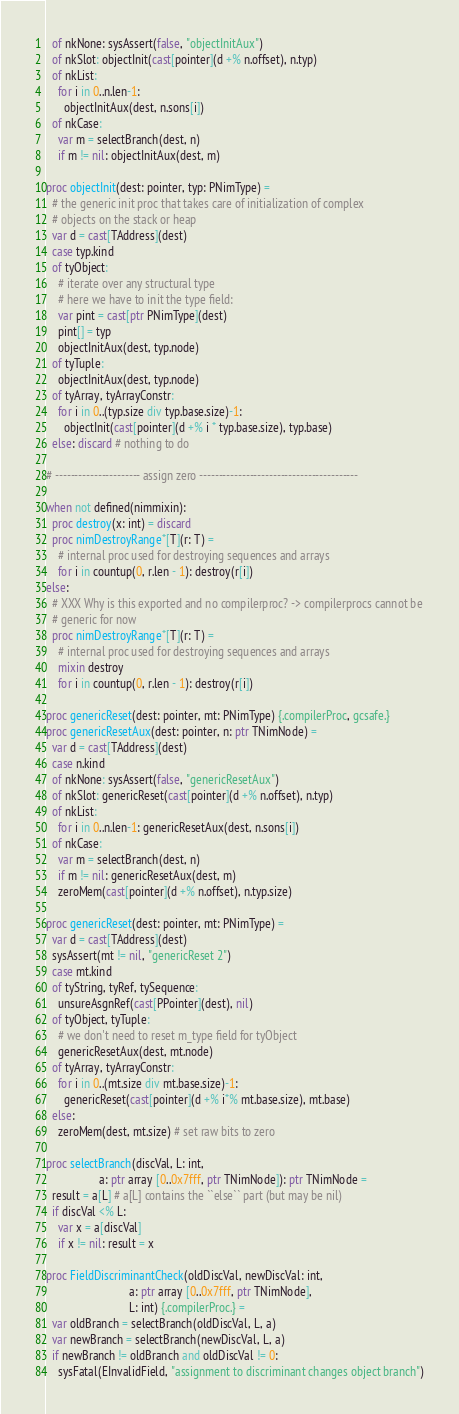<code> <loc_0><loc_0><loc_500><loc_500><_Nim_>  of nkNone: sysAssert(false, "objectInitAux")
  of nkSlot: objectInit(cast[pointer](d +% n.offset), n.typ)
  of nkList:
    for i in 0..n.len-1:
      objectInitAux(dest, n.sons[i])
  of nkCase:
    var m = selectBranch(dest, n)
    if m != nil: objectInitAux(dest, m)

proc objectInit(dest: pointer, typ: PNimType) =
  # the generic init proc that takes care of initialization of complex
  # objects on the stack or heap
  var d = cast[TAddress](dest)
  case typ.kind
  of tyObject:
    # iterate over any structural type
    # here we have to init the type field:
    var pint = cast[ptr PNimType](dest)
    pint[] = typ
    objectInitAux(dest, typ.node)
  of tyTuple:
    objectInitAux(dest, typ.node)
  of tyArray, tyArrayConstr:
    for i in 0..(typ.size div typ.base.size)-1:
      objectInit(cast[pointer](d +% i * typ.base.size), typ.base)
  else: discard # nothing to do
  
# ---------------------- assign zero -----------------------------------------

when not defined(nimmixin):
  proc destroy(x: int) = discard
  proc nimDestroyRange*[T](r: T) =
    # internal proc used for destroying sequences and arrays
    for i in countup(0, r.len - 1): destroy(r[i])
else:
  # XXX Why is this exported and no compilerproc? -> compilerprocs cannot be
  # generic for now
  proc nimDestroyRange*[T](r: T) =
    # internal proc used for destroying sequences and arrays
    mixin destroy
    for i in countup(0, r.len - 1): destroy(r[i])

proc genericReset(dest: pointer, mt: PNimType) {.compilerProc, gcsafe.}
proc genericResetAux(dest: pointer, n: ptr TNimNode) =
  var d = cast[TAddress](dest)
  case n.kind
  of nkNone: sysAssert(false, "genericResetAux")
  of nkSlot: genericReset(cast[pointer](d +% n.offset), n.typ)
  of nkList:
    for i in 0..n.len-1: genericResetAux(dest, n.sons[i])
  of nkCase:
    var m = selectBranch(dest, n)
    if m != nil: genericResetAux(dest, m)
    zeroMem(cast[pointer](d +% n.offset), n.typ.size)
  
proc genericReset(dest: pointer, mt: PNimType) =
  var d = cast[TAddress](dest)
  sysAssert(mt != nil, "genericReset 2")
  case mt.kind
  of tyString, tyRef, tySequence:
    unsureAsgnRef(cast[PPointer](dest), nil)
  of tyObject, tyTuple:
    # we don't need to reset m_type field for tyObject
    genericResetAux(dest, mt.node)
  of tyArray, tyArrayConstr:
    for i in 0..(mt.size div mt.base.size)-1:
      genericReset(cast[pointer](d +% i*% mt.base.size), mt.base)
  else:
    zeroMem(dest, mt.size) # set raw bits to zero

proc selectBranch(discVal, L: int, 
                  a: ptr array [0..0x7fff, ptr TNimNode]): ptr TNimNode =
  result = a[L] # a[L] contains the ``else`` part (but may be nil)
  if discVal <% L:
    var x = a[discVal]
    if x != nil: result = x
  
proc FieldDiscriminantCheck(oldDiscVal, newDiscVal: int, 
                            a: ptr array [0..0x7fff, ptr TNimNode], 
                            L: int) {.compilerProc.} =
  var oldBranch = selectBranch(oldDiscVal, L, a)
  var newBranch = selectBranch(newDiscVal, L, a)
  if newBranch != oldBranch and oldDiscVal != 0:
    sysFatal(EInvalidField, "assignment to discriminant changes object branch")
</code> 